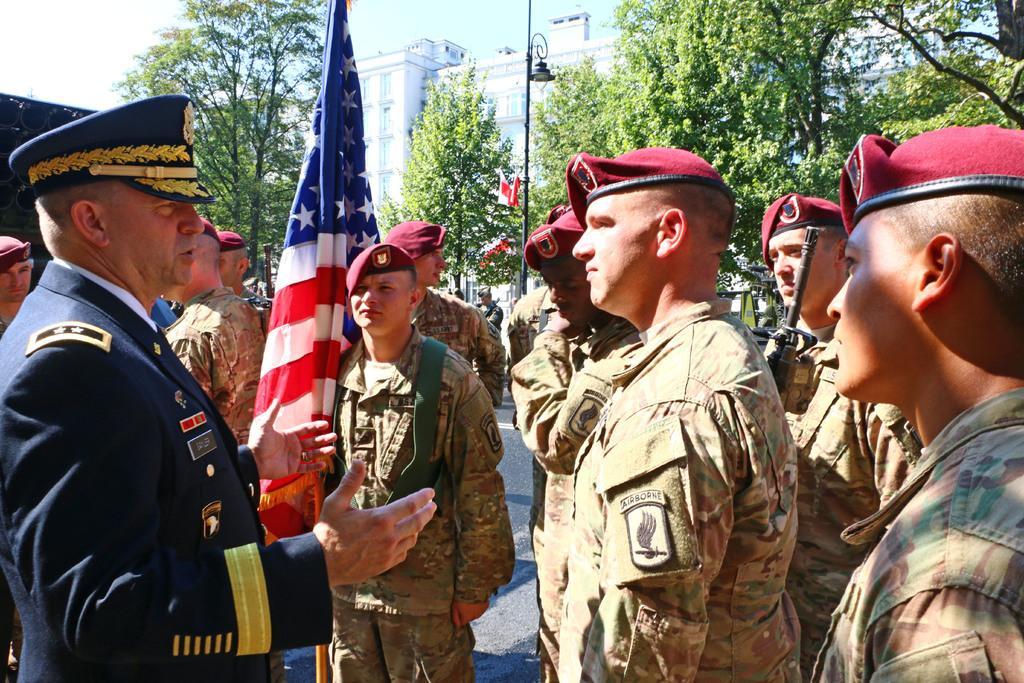How would you summarize this image in a sentence or two? In this picture we can observe some men who are wearing brown color dresses and red color caps on their heads. On the left side there is a man wearing blue color dress and cap on his head. 